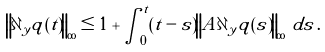Convert formula to latex. <formula><loc_0><loc_0><loc_500><loc_500>\left \| \partial _ { y } q ( t ) \right \| _ { \infty } \leq 1 + \int _ { 0 } ^ { t } ( t - s ) \left \| A \partial _ { y } q ( s ) \right \| _ { \infty } \, d s \, .</formula> 